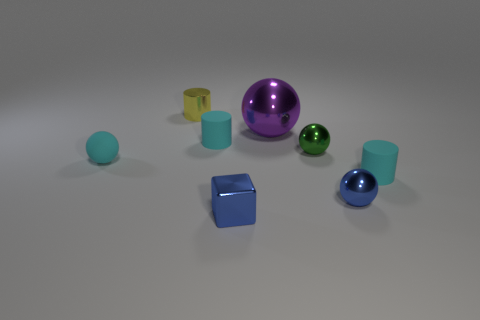Subtract all brown cubes. How many cyan cylinders are left? 2 Subtract all cyan spheres. How many spheres are left? 3 Subtract all big metal balls. How many balls are left? 3 Add 2 small blue things. How many objects exist? 10 Subtract all gray cylinders. Subtract all blue balls. How many cylinders are left? 3 Subtract all cylinders. How many objects are left? 5 Subtract 0 brown cubes. How many objects are left? 8 Subtract all yellow rubber cylinders. Subtract all small blue metallic things. How many objects are left? 6 Add 1 large purple metal spheres. How many large purple metal spheres are left? 2 Add 4 large shiny balls. How many large shiny balls exist? 5 